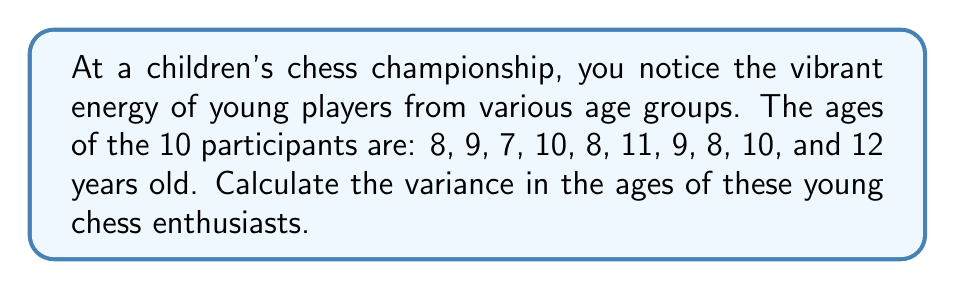Teach me how to tackle this problem. To find the variance, we'll follow these steps:

1) First, calculate the mean age:
   $$\bar{x} = \frac{8 + 9 + 7 + 10 + 8 + 11 + 9 + 8 + 10 + 12}{10} = \frac{92}{10} = 9.2$$

2) Next, subtract the mean from each age and square the difference:
   $$(8 - 9.2)^2 = (-1.2)^2 = 1.44$$
   $$(9 - 9.2)^2 = (-0.2)^2 = 0.04$$
   $$(7 - 9.2)^2 = (-2.2)^2 = 4.84$$
   $$(10 - 9.2)^2 = (0.8)^2 = 0.64$$
   $$(8 - 9.2)^2 = (-1.2)^2 = 1.44$$
   $$(11 - 9.2)^2 = (1.8)^2 = 3.24$$
   $$(9 - 9.2)^2 = (-0.2)^2 = 0.04$$
   $$(8 - 9.2)^2 = (-1.2)^2 = 1.44$$
   $$(10 - 9.2)^2 = (0.8)^2 = 0.64$$
   $$(12 - 9.2)^2 = (2.8)^2 = 7.84$$

3) Sum these squared differences:
   $$1.44 + 0.04 + 4.84 + 0.64 + 1.44 + 3.24 + 0.04 + 1.44 + 0.64 + 7.84 = 21.6$$

4) Divide by the number of participants (10) to get the variance:
   $$\text{Variance} = \frac{21.6}{10} = 2.16$$

Thus, the variance in the ages of the young chess players is 2.16 years squared.
Answer: 2.16 years² 